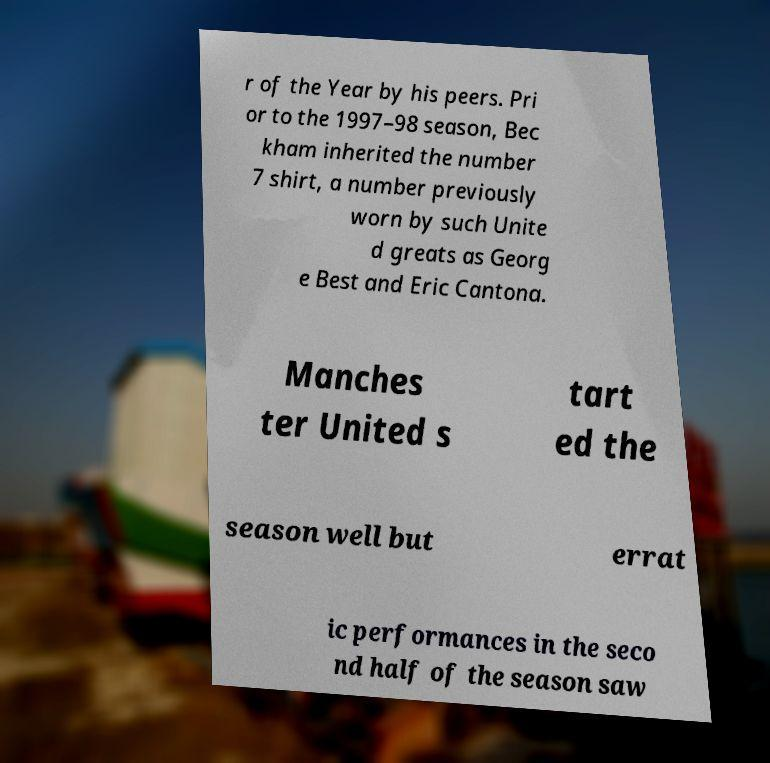There's text embedded in this image that I need extracted. Can you transcribe it verbatim? r of the Year by his peers. Pri or to the 1997–98 season, Bec kham inherited the number 7 shirt, a number previously worn by such Unite d greats as Georg e Best and Eric Cantona. Manches ter United s tart ed the season well but errat ic performances in the seco nd half of the season saw 